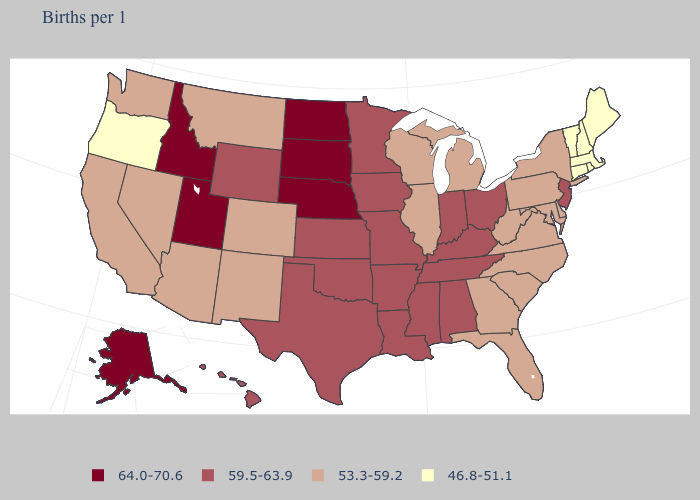Which states have the lowest value in the USA?
Short answer required. Connecticut, Maine, Massachusetts, New Hampshire, Oregon, Rhode Island, Vermont. Name the states that have a value in the range 53.3-59.2?
Quick response, please. Arizona, California, Colorado, Delaware, Florida, Georgia, Illinois, Maryland, Michigan, Montana, Nevada, New Mexico, New York, North Carolina, Pennsylvania, South Carolina, Virginia, Washington, West Virginia, Wisconsin. Name the states that have a value in the range 46.8-51.1?
Short answer required. Connecticut, Maine, Massachusetts, New Hampshire, Oregon, Rhode Island, Vermont. Name the states that have a value in the range 46.8-51.1?
Give a very brief answer. Connecticut, Maine, Massachusetts, New Hampshire, Oregon, Rhode Island, Vermont. How many symbols are there in the legend?
Write a very short answer. 4. Name the states that have a value in the range 46.8-51.1?
Keep it brief. Connecticut, Maine, Massachusetts, New Hampshire, Oregon, Rhode Island, Vermont. What is the value of Ohio?
Answer briefly. 59.5-63.9. Does Montana have the highest value in the USA?
Write a very short answer. No. Name the states that have a value in the range 53.3-59.2?
Be succinct. Arizona, California, Colorado, Delaware, Florida, Georgia, Illinois, Maryland, Michigan, Montana, Nevada, New Mexico, New York, North Carolina, Pennsylvania, South Carolina, Virginia, Washington, West Virginia, Wisconsin. What is the value of Louisiana?
Give a very brief answer. 59.5-63.9. Which states have the lowest value in the USA?
Short answer required. Connecticut, Maine, Massachusetts, New Hampshire, Oregon, Rhode Island, Vermont. What is the lowest value in the Northeast?
Answer briefly. 46.8-51.1. Does the first symbol in the legend represent the smallest category?
Write a very short answer. No. Name the states that have a value in the range 53.3-59.2?
Keep it brief. Arizona, California, Colorado, Delaware, Florida, Georgia, Illinois, Maryland, Michigan, Montana, Nevada, New Mexico, New York, North Carolina, Pennsylvania, South Carolina, Virginia, Washington, West Virginia, Wisconsin. Does Alabama have the lowest value in the USA?
Quick response, please. No. 